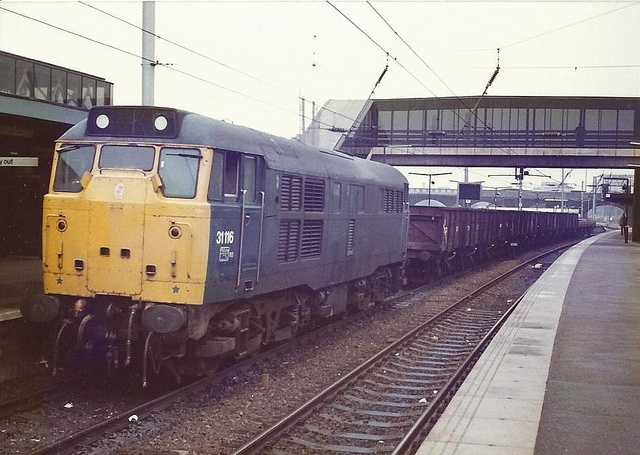Describe the objects in this image and their specific colors. I can see train in gray, purple, black, and tan tones and people in gray and black tones in this image. 